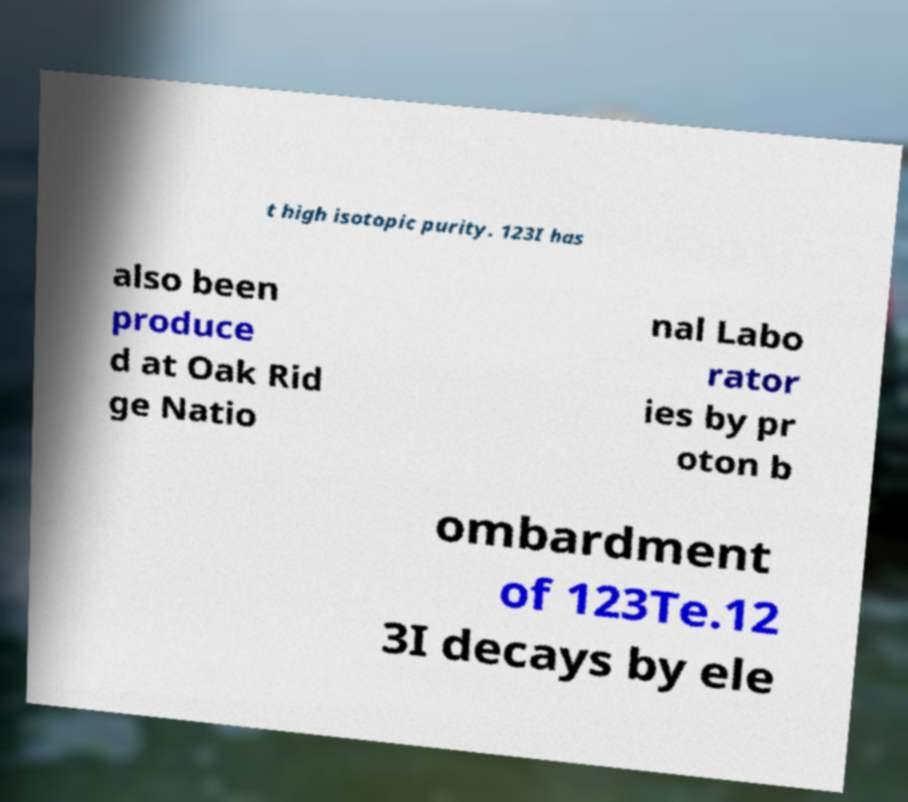Could you extract and type out the text from this image? t high isotopic purity. 123I has also been produce d at Oak Rid ge Natio nal Labo rator ies by pr oton b ombardment of 123Te.12 3I decays by ele 